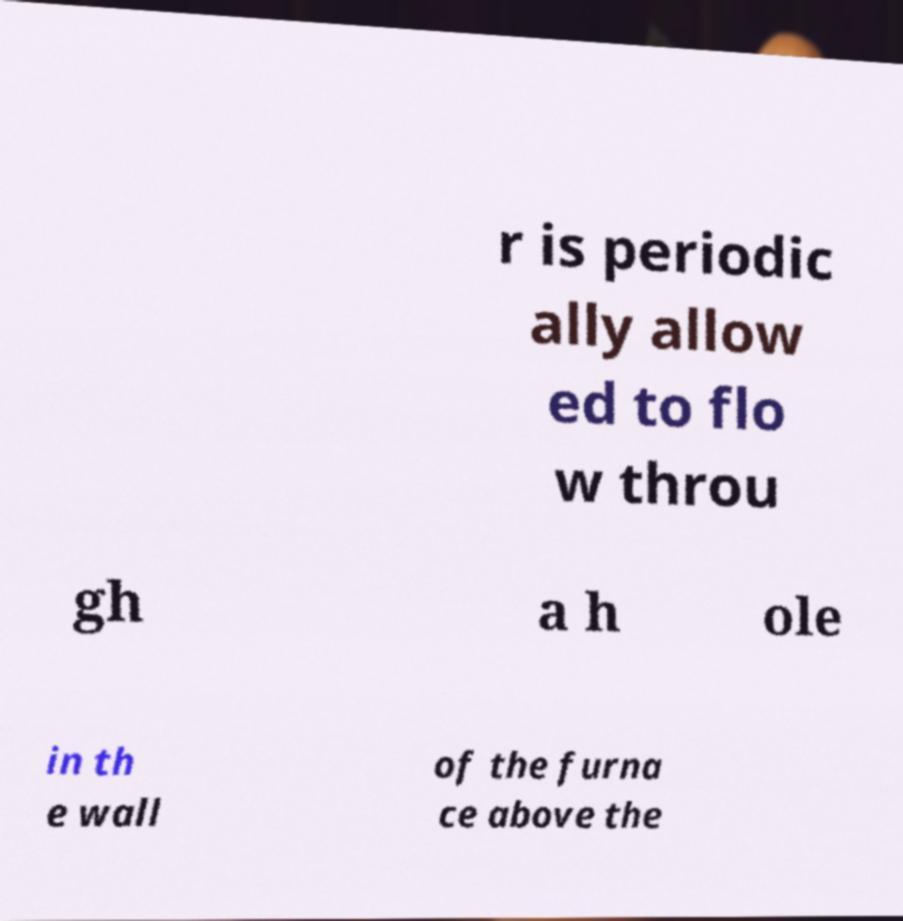I need the written content from this picture converted into text. Can you do that? r is periodic ally allow ed to flo w throu gh a h ole in th e wall of the furna ce above the 